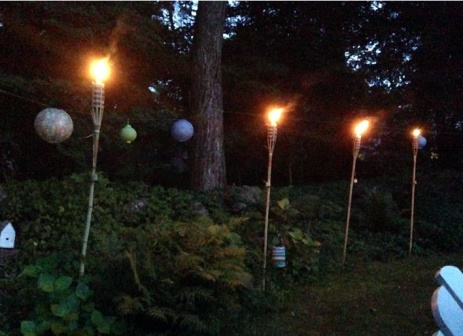Imagine if this scene were part of a movie. What kind of plot or scene might it be part of? In a movie, this scene could be the backdrop for a pivotal moment of reconciliation or romance. Picture a heartfelt conversation under the stars, where characters reconcile their differences surrounded by the serene beauty of the garden, the flickering flames symbolizing renewal and hope. Alternatively, it could be a secret meeting place, where protagonists plan their next move under the cover of night, the tranquil setting contrasting with the tension and intrigue of their clandestine activities. 